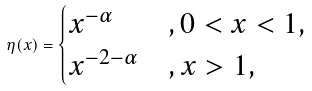<formula> <loc_0><loc_0><loc_500><loc_500>\eta ( x ) = \begin{cases} x ^ { - \alpha } & , 0 < x < 1 , \\ x ^ { - 2 - \alpha } & , x > 1 , \end{cases}</formula> 